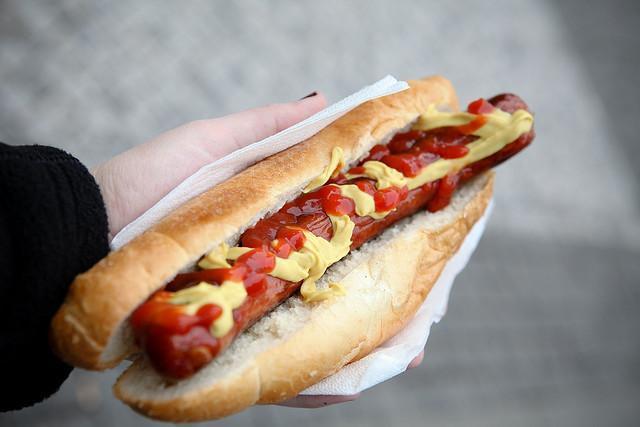How many dogs?
Give a very brief answer. 1. How many people can you see?
Give a very brief answer. 1. How many adult birds are there?
Give a very brief answer. 0. 